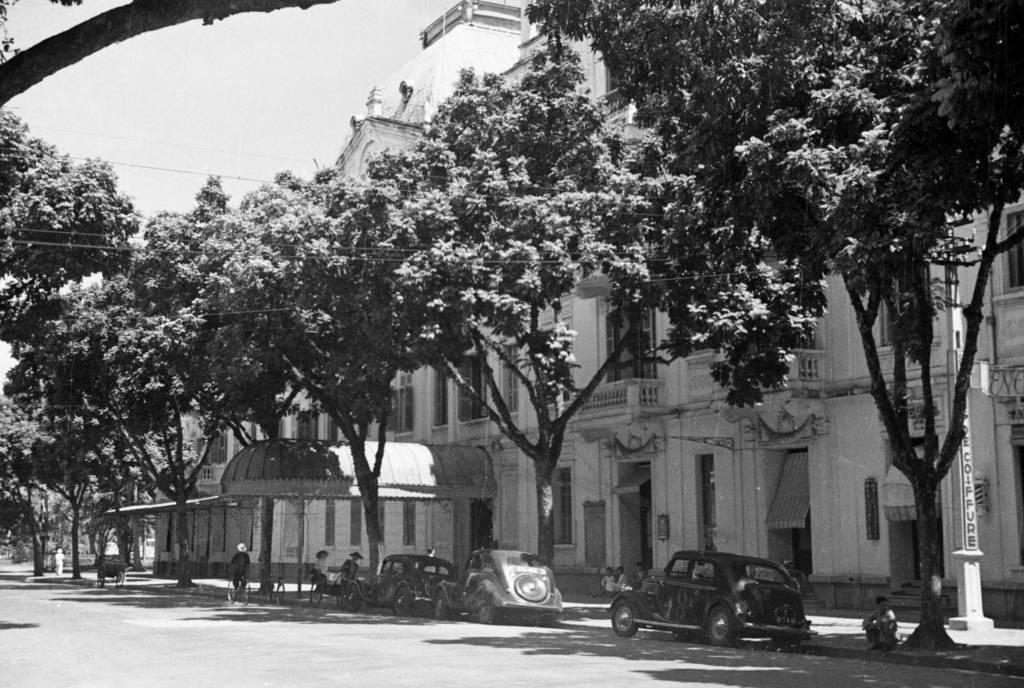Please provide a concise description of this image. In the picture I can see the building on the right side. There are trees on the side of the road. I can see three cars on the road and a person riding a bicycle on the road. 